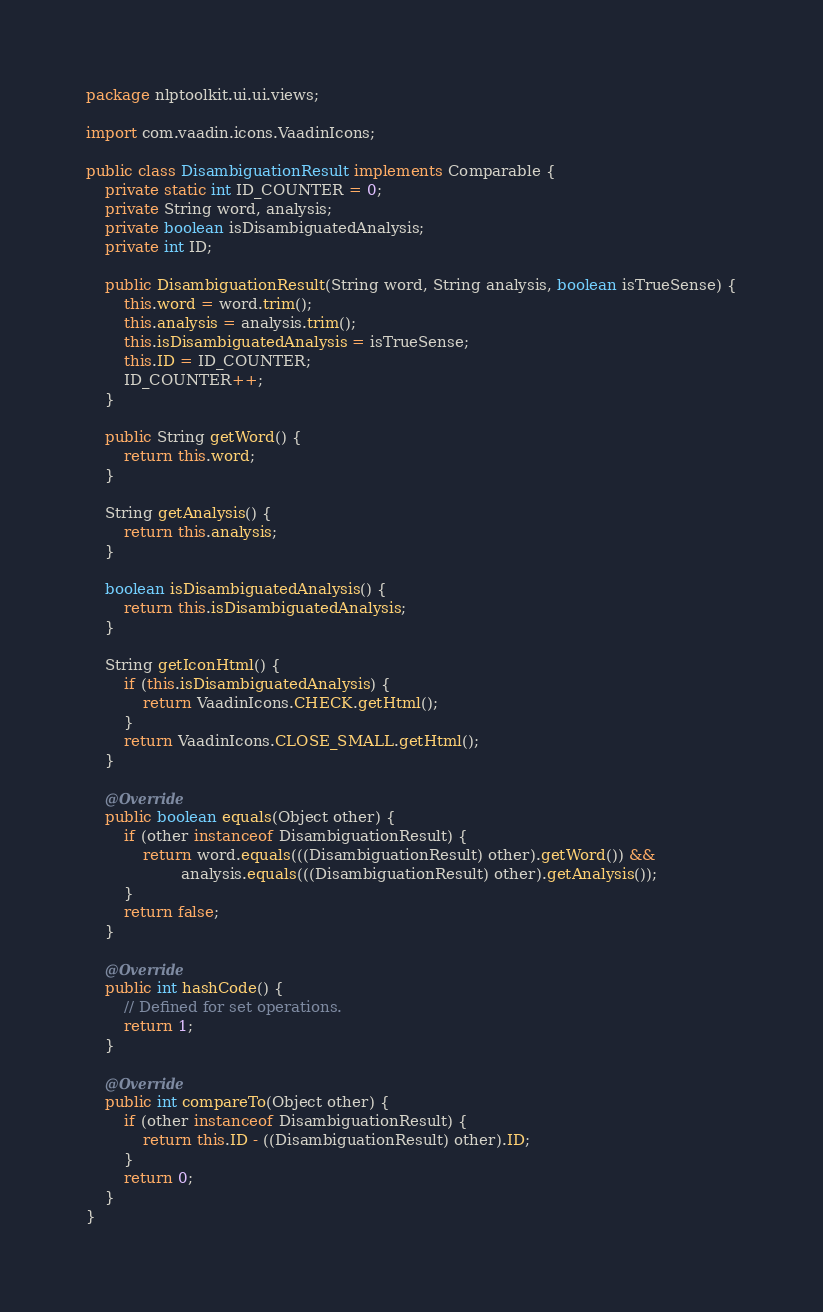<code> <loc_0><loc_0><loc_500><loc_500><_Java_>package nlptoolkit.ui.ui.views;

import com.vaadin.icons.VaadinIcons;

public class DisambiguationResult implements Comparable {
    private static int ID_COUNTER = 0;
    private String word, analysis;
    private boolean isDisambiguatedAnalysis;
    private int ID;

    public DisambiguationResult(String word, String analysis, boolean isTrueSense) {
        this.word = word.trim();
        this.analysis = analysis.trim();
        this.isDisambiguatedAnalysis = isTrueSense;
        this.ID = ID_COUNTER;
        ID_COUNTER++;
    }

    public String getWord() {
        return this.word;
    }

    String getAnalysis() {
        return this.analysis;
    }

    boolean isDisambiguatedAnalysis() {
        return this.isDisambiguatedAnalysis;
    }

    String getIconHtml() {
        if (this.isDisambiguatedAnalysis) {
            return VaadinIcons.CHECK.getHtml();
        }
        return VaadinIcons.CLOSE_SMALL.getHtml();
    }

    @Override
    public boolean equals(Object other) {
        if (other instanceof DisambiguationResult) {
            return word.equals(((DisambiguationResult) other).getWord()) &&
                    analysis.equals(((DisambiguationResult) other).getAnalysis());
        }
        return false;
    }

    @Override
    public int hashCode() {
        // Defined for set operations.
        return 1;
    }

    @Override
    public int compareTo(Object other) {
        if (other instanceof DisambiguationResult) {
            return this.ID - ((DisambiguationResult) other).ID;
        }
        return 0;
    }
}
</code> 